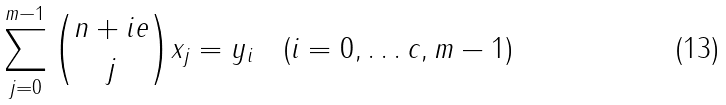Convert formula to latex. <formula><loc_0><loc_0><loc_500><loc_500>\sum _ { j = 0 } ^ { m - 1 } \binom { n + i e } { j } x _ { j } = y _ { i } \quad ( i = 0 , \dots c , m - 1 )</formula> 